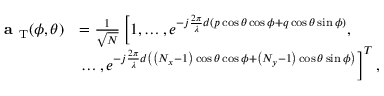Convert formula to latex. <formula><loc_0><loc_0><loc_500><loc_500>\begin{array} { r l } { a _ { T } ( \phi , \theta ) } & { = \frac { 1 } { \sqrt { N } } \left [ 1 , \dots , e ^ { - j \frac { 2 \pi } { \lambda } d \left ( p \cos { \theta } \cos { \phi } + q \cos { \theta } \sin { \phi } \right ) } , } \\ & { \dots , e ^ { - j \frac { 2 \pi } { \lambda } d \left ( \left ( N _ { x } - 1 \right ) \cos { \theta } \cos { \phi } + \left ( N _ { y } - 1 \right ) \cos { \theta } \sin { \phi } \right ) } \right ] ^ { T } , } \end{array}</formula> 